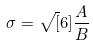<formula> <loc_0><loc_0><loc_500><loc_500>\sigma = \sqrt { [ } 6 ] { \frac { A } { B } }</formula> 